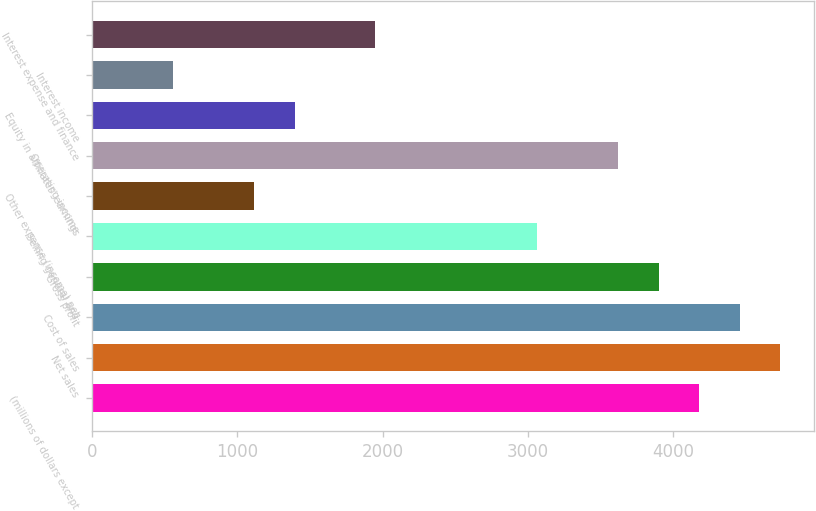Convert chart. <chart><loc_0><loc_0><loc_500><loc_500><bar_chart><fcel>(millions of dollars except<fcel>Net sales<fcel>Cost of sales<fcel>Gross profit<fcel>Selling general and<fcel>Other expense (income) net<fcel>Operating income<fcel>Equity in affiliates' earnings<fcel>Interest income<fcel>Interest expense and finance<nl><fcel>4175.87<fcel>4732.51<fcel>4454.19<fcel>3897.55<fcel>3062.59<fcel>1114.35<fcel>3619.23<fcel>1392.67<fcel>557.71<fcel>1949.31<nl></chart> 